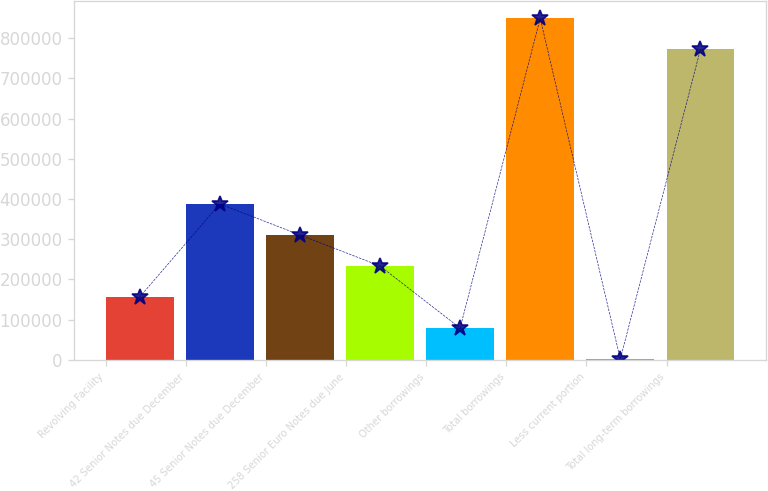Convert chart. <chart><loc_0><loc_0><loc_500><loc_500><bar_chart><fcel>Revolving Facility<fcel>42 Senior Notes due December<fcel>45 Senior Notes due December<fcel>258 Senior Euro Notes due June<fcel>Other borrowings<fcel>Total borrowings<fcel>Less current portion<fcel>Total long-term borrowings<nl><fcel>156272<fcel>387874<fcel>310673<fcel>233472<fcel>79071.5<fcel>849206<fcel>1871<fcel>772005<nl></chart> 